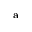Convert formula to latex. <formula><loc_0><loc_0><loc_500><loc_500>^ { a }</formula> 